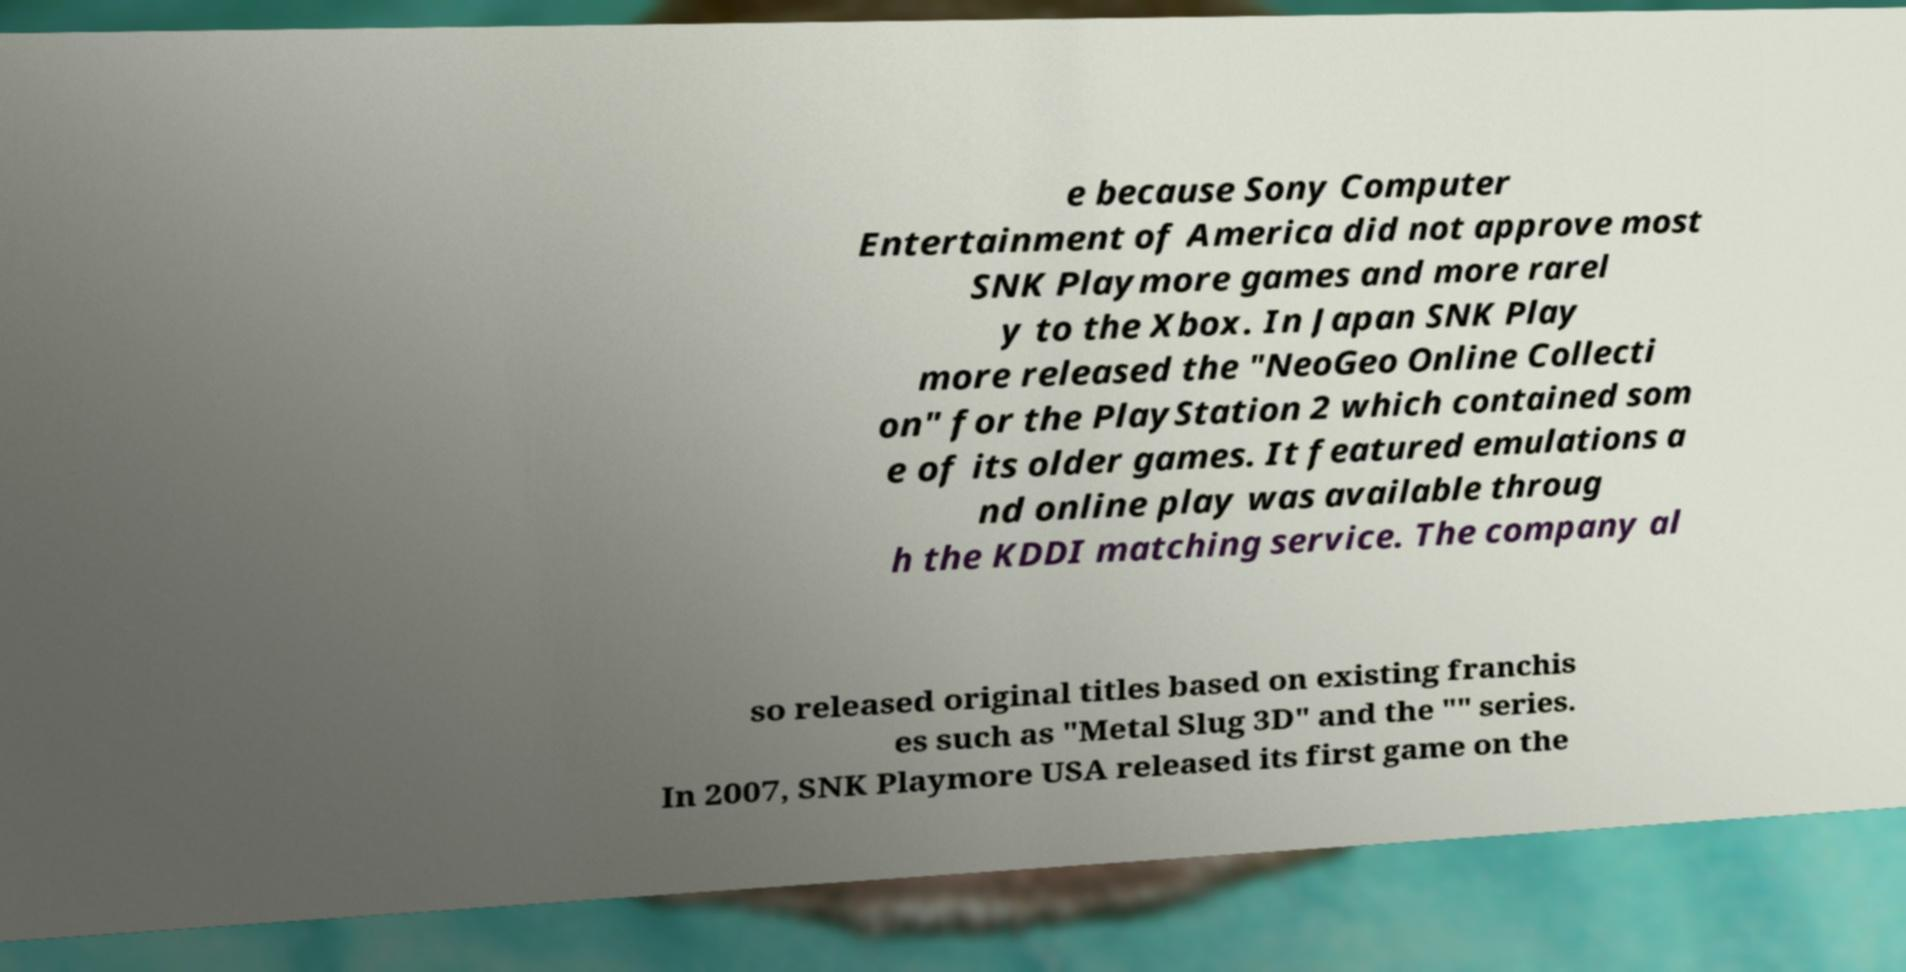Could you assist in decoding the text presented in this image and type it out clearly? e because Sony Computer Entertainment of America did not approve most SNK Playmore games and more rarel y to the Xbox. In Japan SNK Play more released the "NeoGeo Online Collecti on" for the PlayStation 2 which contained som e of its older games. It featured emulations a nd online play was available throug h the KDDI matching service. The company al so released original titles based on existing franchis es such as "Metal Slug 3D" and the "" series. In 2007, SNK Playmore USA released its first game on the 